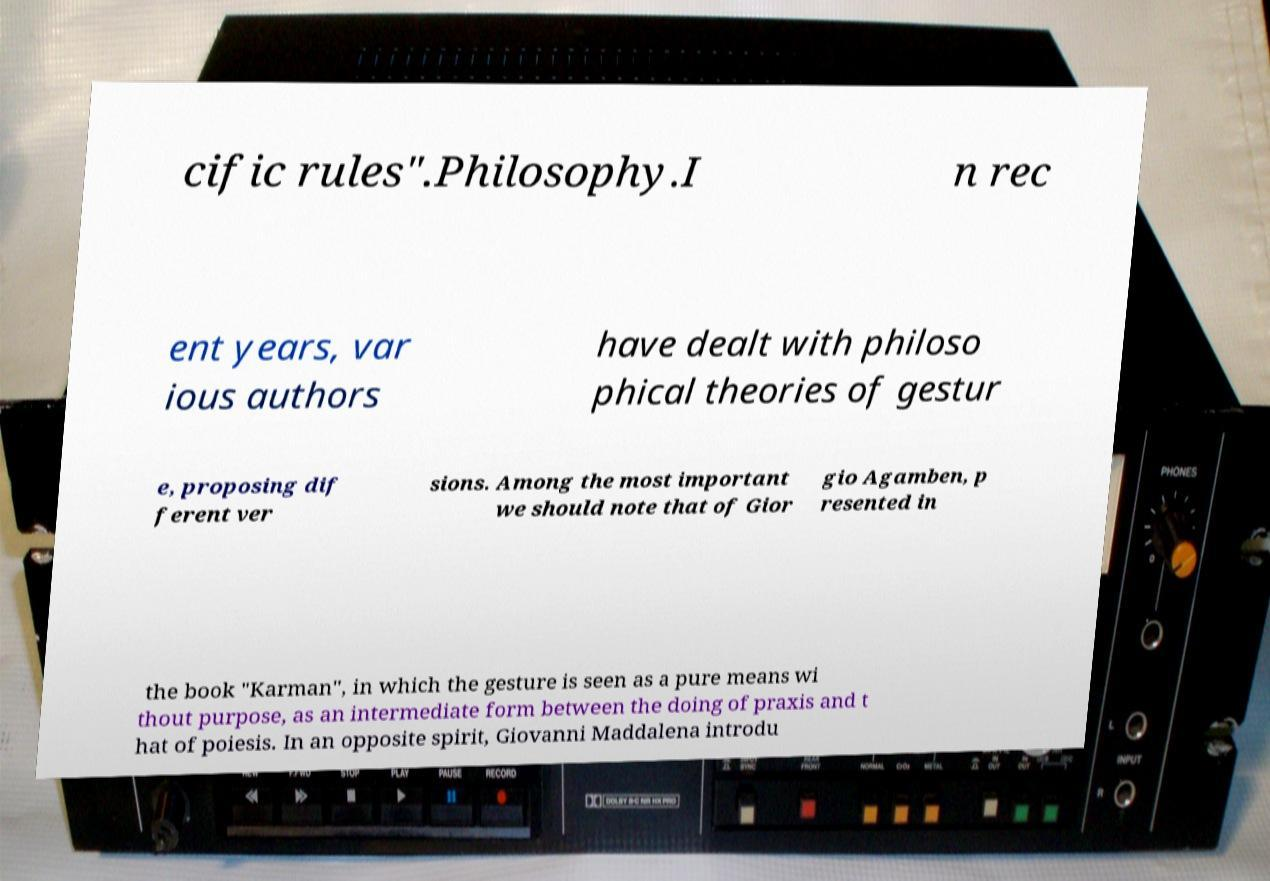Can you accurately transcribe the text from the provided image for me? cific rules".Philosophy.I n rec ent years, var ious authors have dealt with philoso phical theories of gestur e, proposing dif ferent ver sions. Among the most important we should note that of Gior gio Agamben, p resented in the book "Karman", in which the gesture is seen as a pure means wi thout purpose, as an intermediate form between the doing of praxis and t hat of poiesis. In an opposite spirit, Giovanni Maddalena introdu 